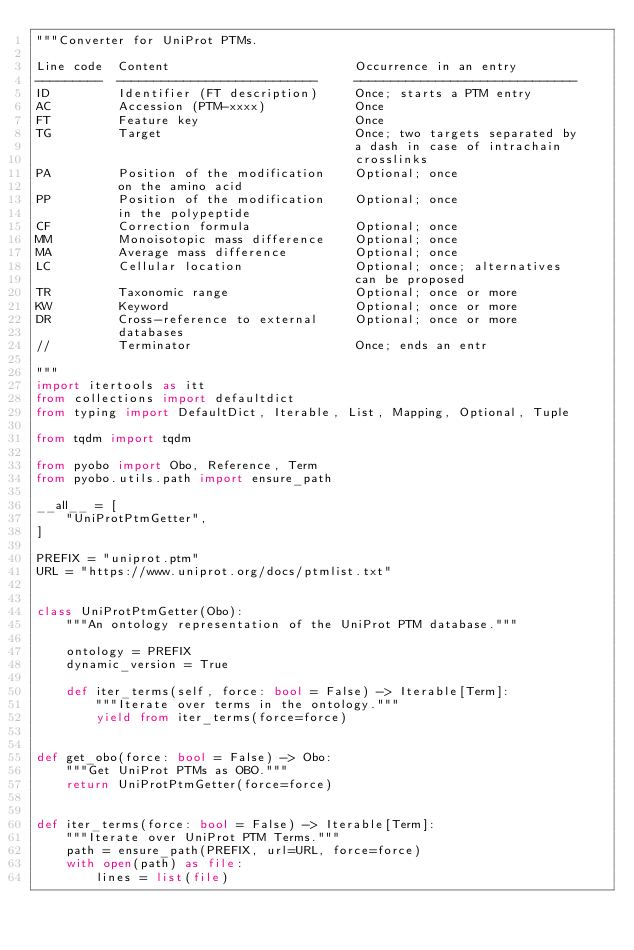<code> <loc_0><loc_0><loc_500><loc_500><_Python_>"""Converter for UniProt PTMs.

Line code  Content                         Occurrence in an entry
---------  ---------------------------     ------------------------------
ID         Identifier (FT description)     Once; starts a PTM entry
AC         Accession (PTM-xxxx)            Once
FT         Feature key                     Once
TG         Target                          Once; two targets separated by
                                           a dash in case of intrachain
                                           crosslinks
PA         Position of the modification    Optional; once
           on the amino acid
PP         Position of the modification    Optional; once
           in the polypeptide
CF         Correction formula              Optional; once
MM         Monoisotopic mass difference    Optional; once
MA         Average mass difference         Optional; once
LC         Cellular location               Optional; once; alternatives
                                           can be proposed
TR         Taxonomic range                 Optional; once or more
KW         Keyword                         Optional; once or more
DR         Cross-reference to external     Optional; once or more
           databases
//         Terminator                      Once; ends an entr

"""
import itertools as itt
from collections import defaultdict
from typing import DefaultDict, Iterable, List, Mapping, Optional, Tuple

from tqdm import tqdm

from pyobo import Obo, Reference, Term
from pyobo.utils.path import ensure_path

__all__ = [
    "UniProtPtmGetter",
]

PREFIX = "uniprot.ptm"
URL = "https://www.uniprot.org/docs/ptmlist.txt"


class UniProtPtmGetter(Obo):
    """An ontology representation of the UniProt PTM database."""

    ontology = PREFIX
    dynamic_version = True

    def iter_terms(self, force: bool = False) -> Iterable[Term]:
        """Iterate over terms in the ontology."""
        yield from iter_terms(force=force)


def get_obo(force: bool = False) -> Obo:
    """Get UniProt PTMs as OBO."""
    return UniProtPtmGetter(force=force)


def iter_terms(force: bool = False) -> Iterable[Term]:
    """Iterate over UniProt PTM Terms."""
    path = ensure_path(PREFIX, url=URL, force=force)
    with open(path) as file:
        lines = list(file)</code> 